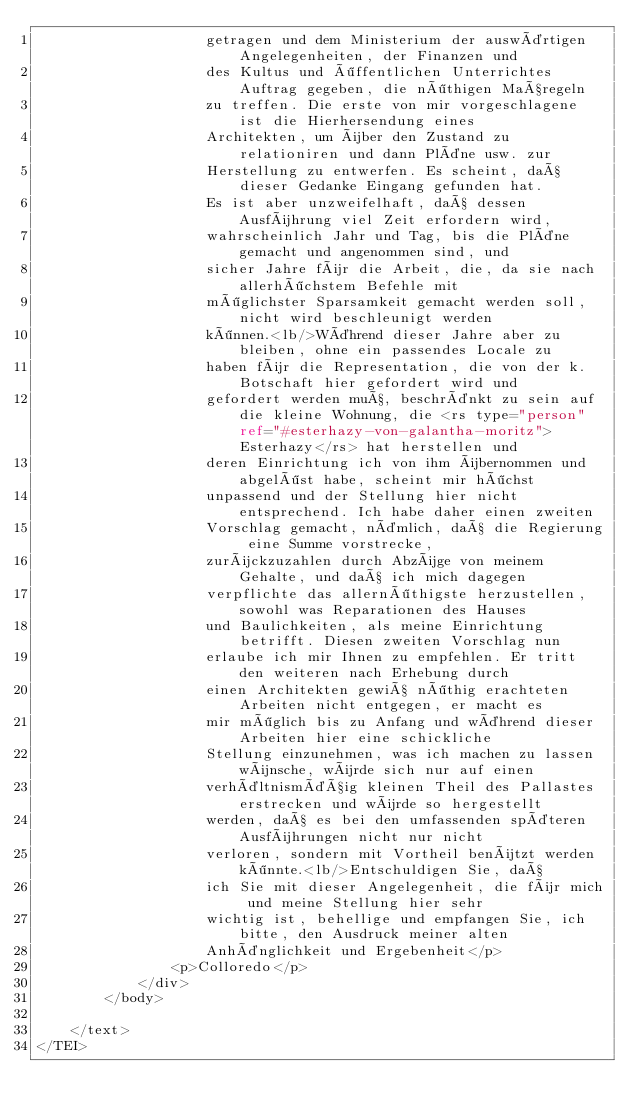Convert code to text. <code><loc_0><loc_0><loc_500><loc_500><_XML_>                    getragen und dem Ministerium der auswärtigen Angelegenheiten, der Finanzen und
                    des Kultus und öffentlichen Unterrichtes Auftrag gegeben, die nöthigen Maßregeln
                    zu treffen. Die erste von mir vorgeschlagene ist die Hierhersendung eines
                    Architekten, um über den Zustand zu relationiren und dann Pläne usw. zur
                    Herstellung zu entwerfen. Es scheint, daß dieser Gedanke Eingang gefunden hat.
                    Es ist aber unzweifelhaft, daß dessen Ausführung viel Zeit erfordern wird,
                    wahrscheinlich Jahr und Tag, bis die Pläne gemacht und angenommen sind, und
                    sicher Jahre für die Arbeit, die, da sie nach allerhöchstem Befehle mit
                    möglichster Sparsamkeit gemacht werden soll, nicht wird beschleunigt werden
                    können.<lb/>Während dieser Jahre aber zu bleiben, ohne ein passendes Locale zu
                    haben für die Representation, die von der k. Botschaft hier gefordert wird und
                    gefordert werden muß, beschränkt zu sein auf die kleine Wohnung, die <rs type="person" ref="#esterhazy-von-galantha-moritz">Esterhazy</rs> hat herstellen und
                    deren Einrichtung ich von ihm übernommen und abgelöst habe, scheint mir höchst
                    unpassend und der Stellung hier nicht entsprechend. Ich habe daher einen zweiten
                    Vorschlag gemacht, nämlich, daß die Regierung eine Summe vorstrecke,
                    zurückzuzahlen durch Abzüge von meinem Gehalte, und daß ich mich dagegen
                    verpflichte das allernöthigste herzustellen, sowohl was Reparationen des Hauses
                    und Baulichkeiten, als meine Einrichtung betrifft. Diesen zweiten Vorschlag nun
                    erlaube ich mir Ihnen zu empfehlen. Er tritt den weiteren nach Erhebung durch
                    einen Architekten gewiß nöthig erachteten Arbeiten nicht entgegen, er macht es
                    mir möglich bis zu Anfang und während dieser Arbeiten hier eine schickliche
                    Stellung einzunehmen, was ich machen zu lassen wünsche, würde sich nur auf einen
                    verhältnismäßig kleinen Theil des Pallastes erstrecken und würde so hergestellt
                    werden, daß es bei den umfassenden späteren Ausführungen nicht nur nicht
                    verloren, sondern mit Vortheil benützt werden könnte.<lb/>Entschuldigen Sie, daß
                    ich Sie mit dieser Angelegenheit, die für mich und meine Stellung hier sehr
                    wichtig ist, behellige und empfangen Sie, ich bitte, den Ausdruck meiner alten
                    Anhänglichkeit und Ergebenheit</p>
                <p>Colloredo</p>
            </div>
        </body>
    
    </text>
</TEI></code> 